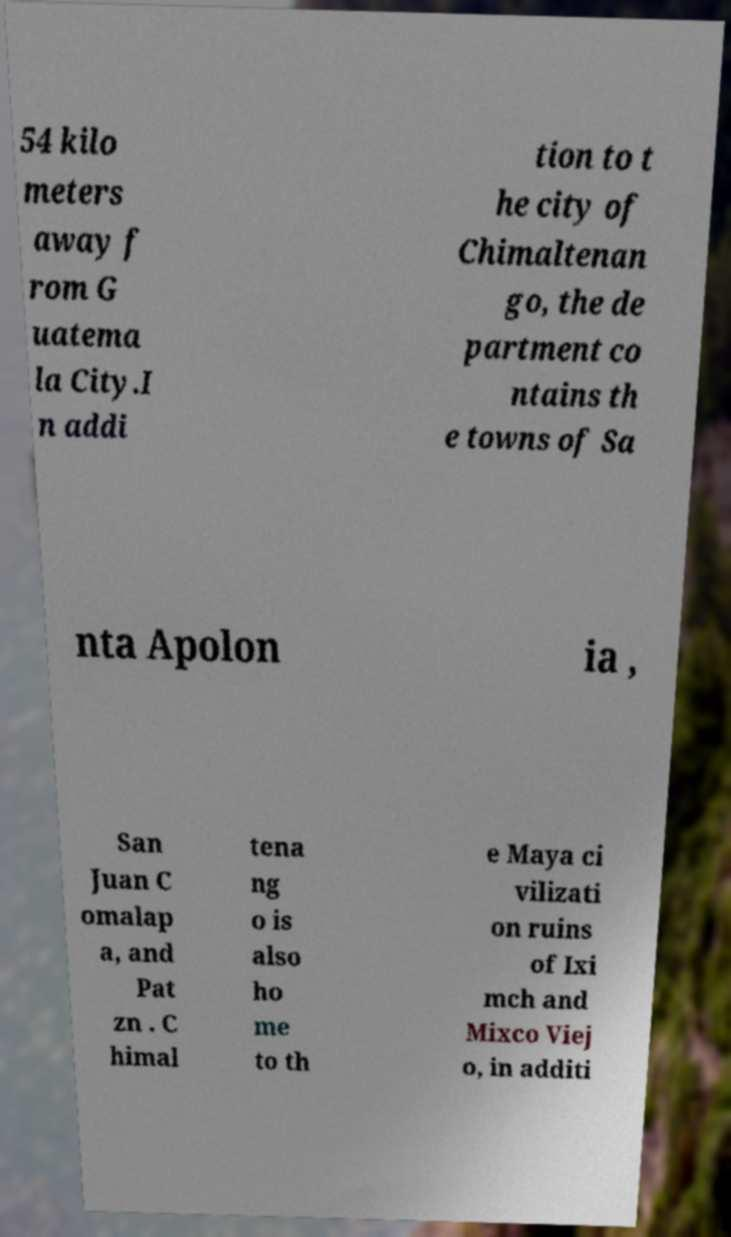Can you read and provide the text displayed in the image?This photo seems to have some interesting text. Can you extract and type it out for me? 54 kilo meters away f rom G uatema la City.I n addi tion to t he city of Chimaltenan go, the de partment co ntains th e towns of Sa nta Apolon ia , San Juan C omalap a, and Pat zn . C himal tena ng o is also ho me to th e Maya ci vilizati on ruins of Ixi mch and Mixco Viej o, in additi 